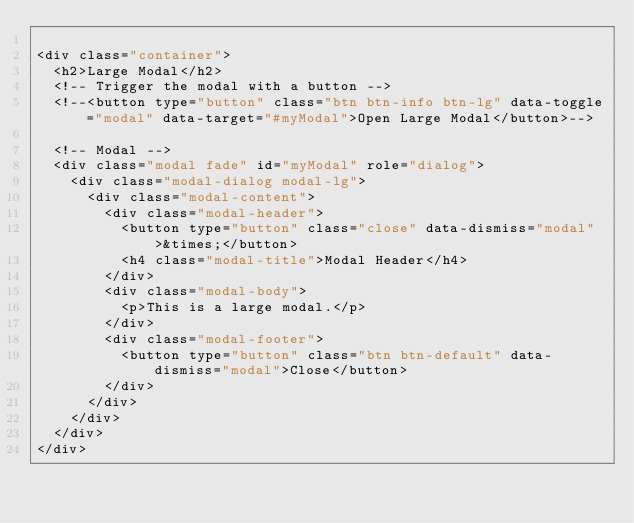<code> <loc_0><loc_0><loc_500><loc_500><_PHP_>
<div class="container">
  <h2>Large Modal</h2>
  <!-- Trigger the modal with a button -->
  <!--<button type="button" class="btn btn-info btn-lg" data-toggle="modal" data-target="#myModal">Open Large Modal</button>-->

  <!-- Modal -->
  <div class="modal fade" id="myModal" role="dialog">
    <div class="modal-dialog modal-lg">
      <div class="modal-content">
        <div class="modal-header">
          <button type="button" class="close" data-dismiss="modal">&times;</button>
          <h4 class="modal-title">Modal Header</h4>
        </div>
        <div class="modal-body">
          <p>This is a large modal.</p>
        </div>
        <div class="modal-footer">
          <button type="button" class="btn btn-default" data-dismiss="modal">Close</button>
        </div>
      </div>
    </div>
  </div>
</div>
</code> 